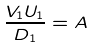<formula> <loc_0><loc_0><loc_500><loc_500>\frac { V _ { 1 } U _ { 1 } } { D _ { 1 } } = A</formula> 